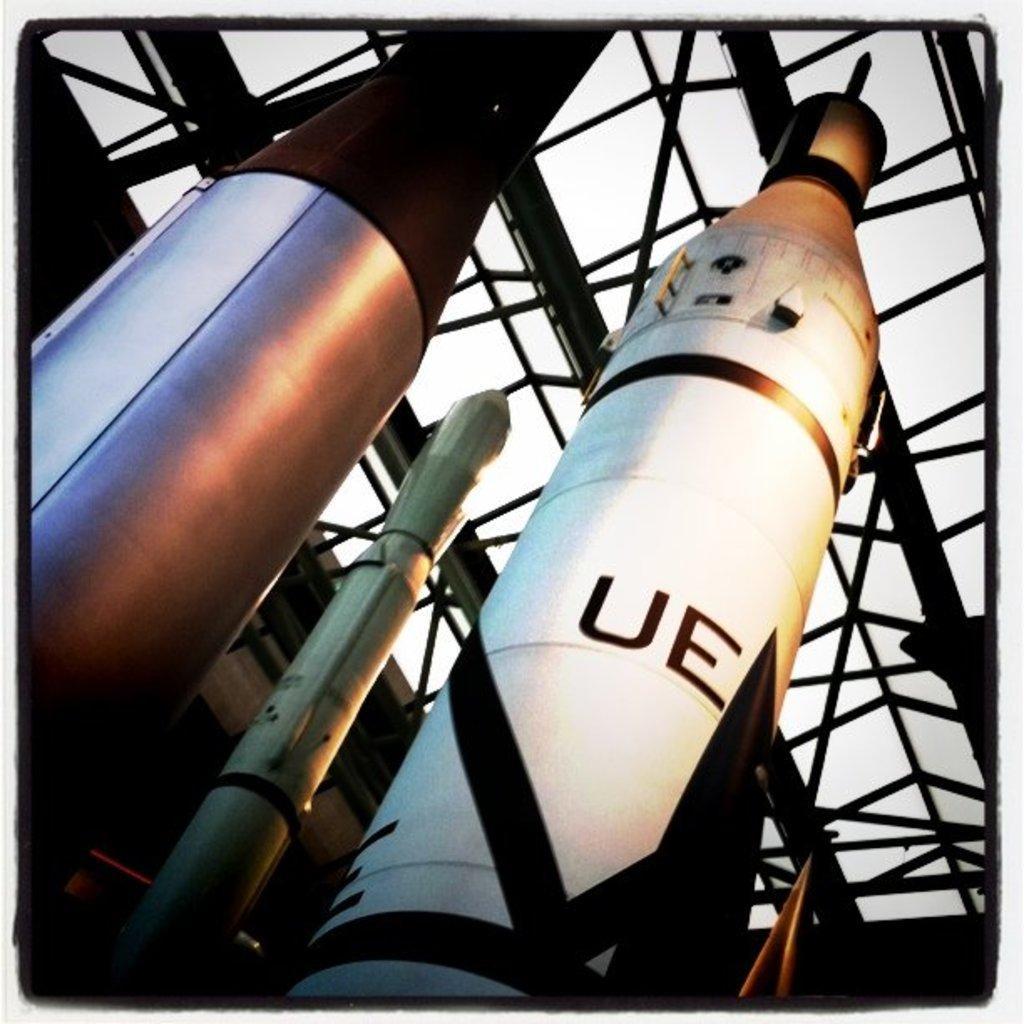Describe this image in one or two sentences. In this image we can see some parts of an aerospace. We can also see a metal frame and the sky. 